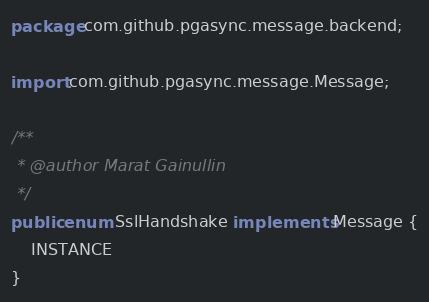Convert code to text. <code><loc_0><loc_0><loc_500><loc_500><_Java_>package com.github.pgasync.message.backend;

import com.github.pgasync.message.Message;

/**
 * @author Marat Gainullin
 */
public enum SslHandshake implements Message {
    INSTANCE
}
</code> 